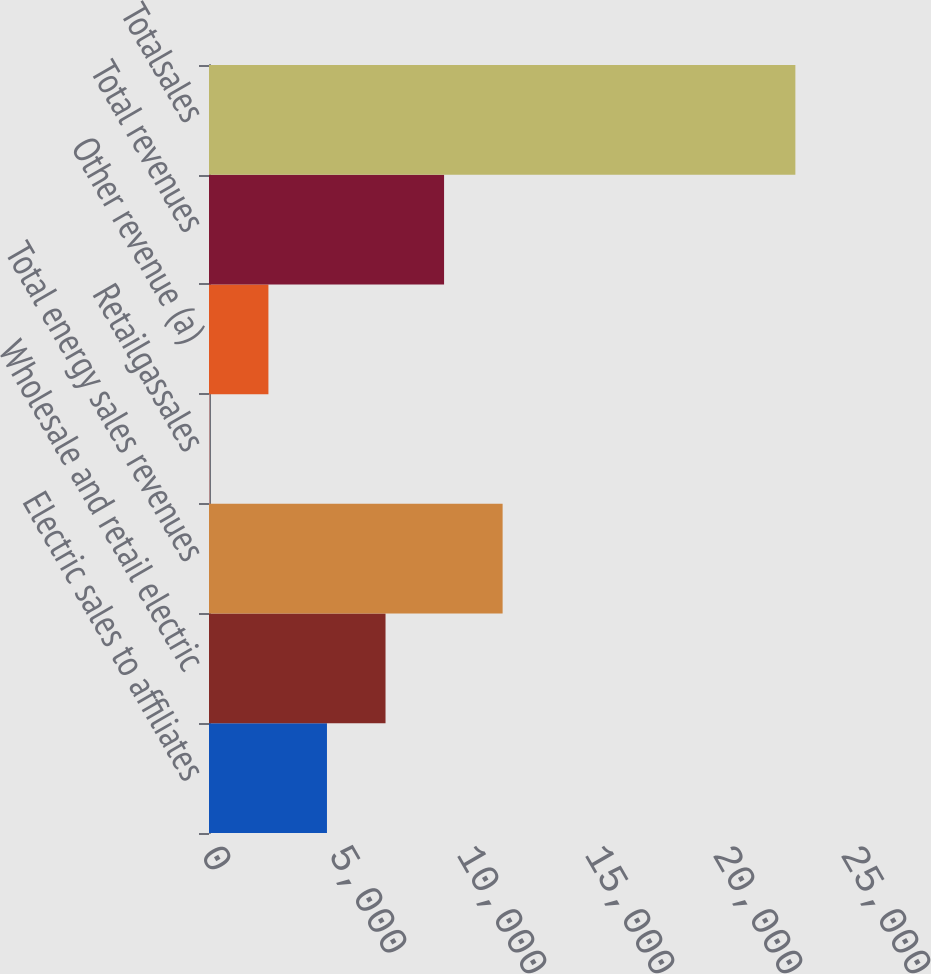Convert chart. <chart><loc_0><loc_0><loc_500><loc_500><bar_chart><fcel>Electric sales to affiliates<fcel>Wholesale and retail electric<fcel>Total energy sales revenues<fcel>Retailgassales<fcel>Other revenue (a)<fcel>Total revenues<fcel>Totalsales<nl><fcel>4608.2<fcel>6895.3<fcel>11469.5<fcel>34<fcel>2321.1<fcel>9182.4<fcel>22905<nl></chart> 